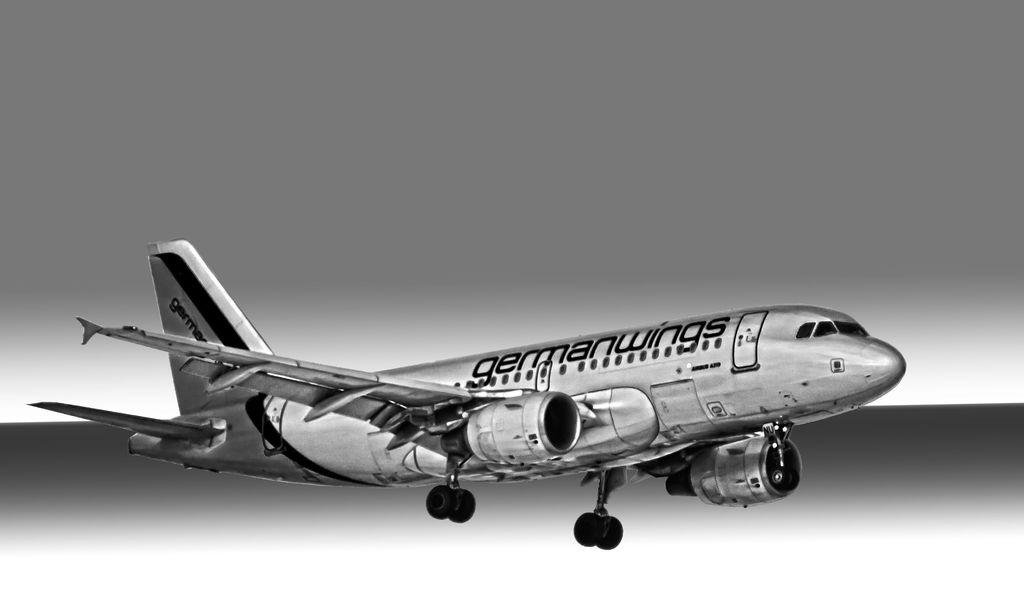What is the main subject of the image? There is an aeroplane in the center of the image. Can you describe the aeroplane in the image? The aeroplane is the main subject and is located in the center of the image. Are there any other objects or elements in the image besides the aeroplane? The provided facts do not mention any other objects or elements in the image. What type of sugar is being used in the battle depicted in the image? There is no battle or sugar present in the image; it features an aeroplane in the center. What company is responsible for manufacturing the aeroplane in the image? The provided facts do not mention the manufacturer of the aeroplane, so we cannot determine the company responsible for it. 